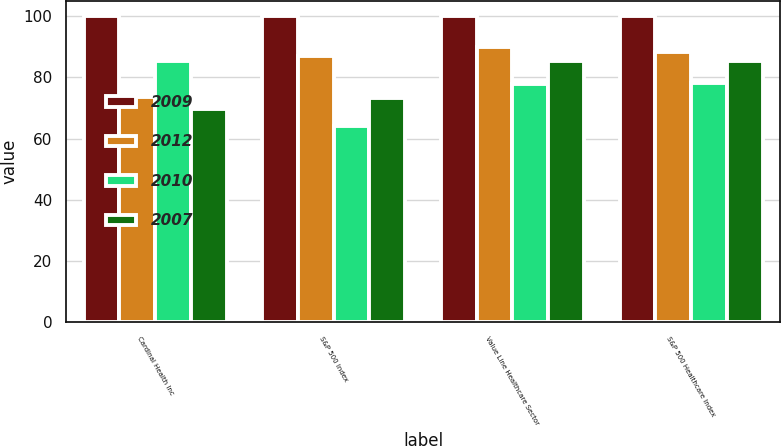Convert chart. <chart><loc_0><loc_0><loc_500><loc_500><stacked_bar_chart><ecel><fcel>Cardinal Health Inc<fcel>S&P 500 Index<fcel>Value Line Healthcare Sector<fcel>S&P 500 Healthcare Index<nl><fcel>2009<fcel>100<fcel>100<fcel>100<fcel>100<nl><fcel>2012<fcel>73.68<fcel>86.88<fcel>89.88<fcel>88.28<nl><fcel>2010<fcel>85.2<fcel>64.11<fcel>77.82<fcel>78.15<nl><fcel>2007<fcel>69.56<fcel>73.36<fcel>85.2<fcel>85.18<nl></chart> 